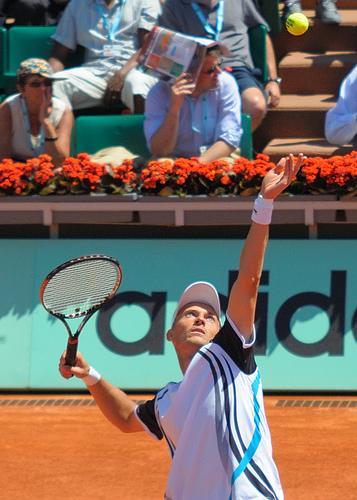What sport is this?
Be succinct. Tennis. What color are the flowers?
Answer briefly. Orange. What are the horse and rider doing?
Quick response, please. Nothing. Is it sunny?
Short answer required. Yes. 